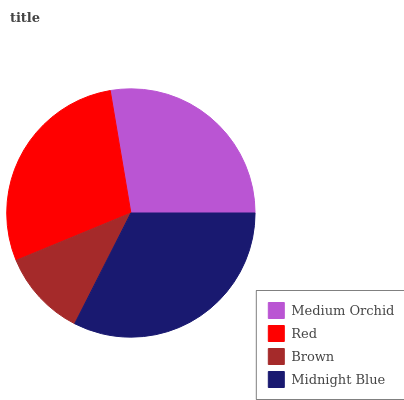Is Brown the minimum?
Answer yes or no. Yes. Is Midnight Blue the maximum?
Answer yes or no. Yes. Is Red the minimum?
Answer yes or no. No. Is Red the maximum?
Answer yes or no. No. Is Red greater than Medium Orchid?
Answer yes or no. Yes. Is Medium Orchid less than Red?
Answer yes or no. Yes. Is Medium Orchid greater than Red?
Answer yes or no. No. Is Red less than Medium Orchid?
Answer yes or no. No. Is Red the high median?
Answer yes or no. Yes. Is Medium Orchid the low median?
Answer yes or no. Yes. Is Medium Orchid the high median?
Answer yes or no. No. Is Midnight Blue the low median?
Answer yes or no. No. 